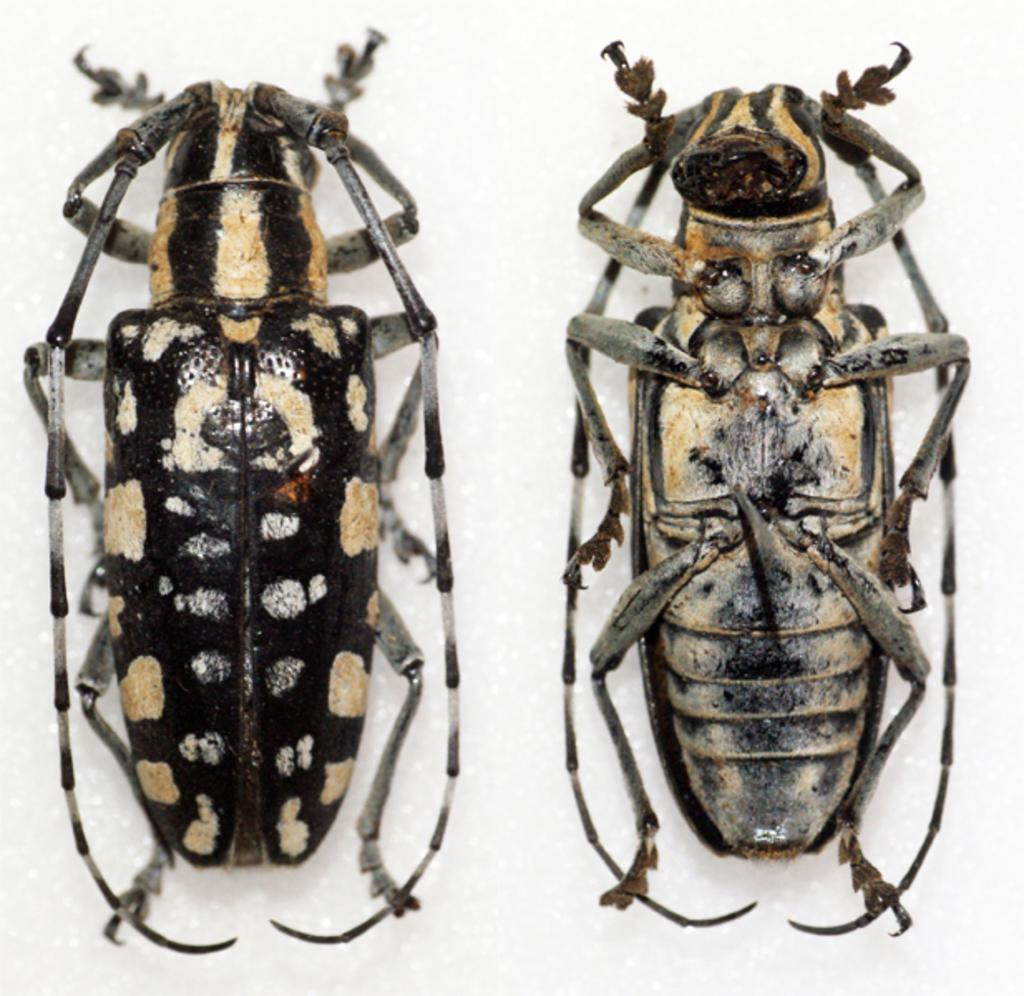What creatures are present in the image? There are two cockroaches in the image. What is the color of the surface where the cockroaches are located? The cockroaches are on a white surface. What type of breakfast is being served on the waves in the image? There are no waves or breakfast present in the image; it only features two cockroaches on a white surface. 